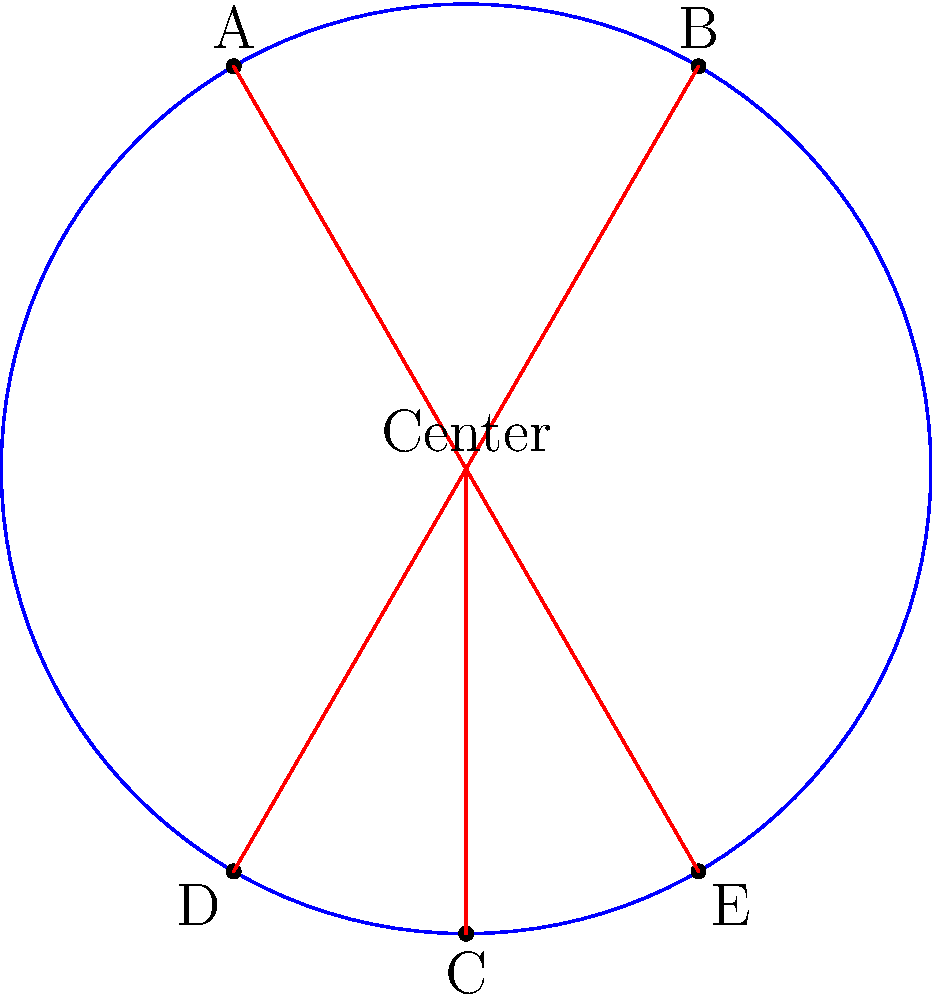As an amateur hockey player, you're practicing face-offs at different positions on the rink. The diagram shows a simplified circular rink with radius 5 meters and five face-off spots (A, B, C, D, and E). If the angle between OA and OB is 60°, and the angle between OC and OD is 120°, what is the angle (in degrees) between OD and OE? Let's approach this step-by-step:

1) First, we need to understand the symmetry of the rink. The face-off spots are symmetrically placed around the circle.

2) We're given that angle AOB = 60°. Since the rink is circular, we can deduce that:
   - Angle AOC = 90° (quarter of a circle)
   - Angle COD = 120° (given in the question)

3) Now, let's calculate the total angle we know:
   $60° + 90° + 120° = 270°$

4) A full circle has 360°. So, the remaining angle must be:
   $360° - 270° = 90°$

5) This remaining 90° must be split equally between the angles DOE and EOB due to the symmetry of the rink.

6) Therefore, angle DOE = angle EOB = $90° ÷ 2 = 45°$

Thus, the angle between OD and OE is 45°.
Answer: 45° 